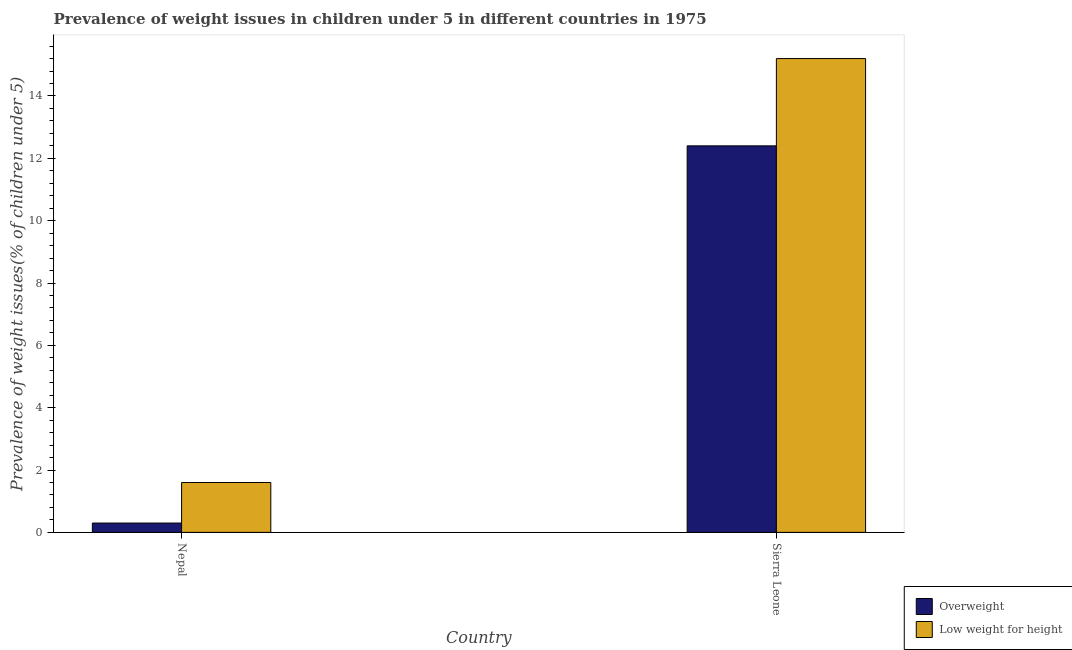How many groups of bars are there?
Make the answer very short. 2. Are the number of bars on each tick of the X-axis equal?
Your answer should be very brief. Yes. How many bars are there on the 2nd tick from the right?
Make the answer very short. 2. What is the label of the 1st group of bars from the left?
Provide a short and direct response. Nepal. In how many cases, is the number of bars for a given country not equal to the number of legend labels?
Keep it short and to the point. 0. What is the percentage of underweight children in Sierra Leone?
Your answer should be compact. 15.2. Across all countries, what is the maximum percentage of underweight children?
Your answer should be compact. 15.2. Across all countries, what is the minimum percentage of underweight children?
Provide a succinct answer. 1.6. In which country was the percentage of overweight children maximum?
Offer a very short reply. Sierra Leone. In which country was the percentage of overweight children minimum?
Ensure brevity in your answer.  Nepal. What is the total percentage of underweight children in the graph?
Your answer should be very brief. 16.8. What is the difference between the percentage of underweight children in Nepal and that in Sierra Leone?
Keep it short and to the point. -13.6. What is the difference between the percentage of underweight children in Sierra Leone and the percentage of overweight children in Nepal?
Your answer should be very brief. 14.9. What is the average percentage of underweight children per country?
Give a very brief answer. 8.4. What is the difference between the percentage of underweight children and percentage of overweight children in Nepal?
Ensure brevity in your answer.  1.3. In how many countries, is the percentage of underweight children greater than 4.4 %?
Offer a terse response. 1. What is the ratio of the percentage of overweight children in Nepal to that in Sierra Leone?
Your response must be concise. 0.02. What does the 1st bar from the left in Sierra Leone represents?
Give a very brief answer. Overweight. What does the 1st bar from the right in Sierra Leone represents?
Ensure brevity in your answer.  Low weight for height. How many bars are there?
Your response must be concise. 4. Are all the bars in the graph horizontal?
Ensure brevity in your answer.  No. How many countries are there in the graph?
Your answer should be very brief. 2. What is the difference between two consecutive major ticks on the Y-axis?
Offer a terse response. 2. Are the values on the major ticks of Y-axis written in scientific E-notation?
Your answer should be very brief. No. Does the graph contain any zero values?
Your answer should be compact. No. How are the legend labels stacked?
Ensure brevity in your answer.  Vertical. What is the title of the graph?
Provide a succinct answer. Prevalence of weight issues in children under 5 in different countries in 1975. Does "Automatic Teller Machines" appear as one of the legend labels in the graph?
Provide a succinct answer. No. What is the label or title of the Y-axis?
Give a very brief answer. Prevalence of weight issues(% of children under 5). What is the Prevalence of weight issues(% of children under 5) of Overweight in Nepal?
Your response must be concise. 0.3. What is the Prevalence of weight issues(% of children under 5) in Low weight for height in Nepal?
Offer a very short reply. 1.6. What is the Prevalence of weight issues(% of children under 5) in Overweight in Sierra Leone?
Make the answer very short. 12.4. What is the Prevalence of weight issues(% of children under 5) of Low weight for height in Sierra Leone?
Your answer should be compact. 15.2. Across all countries, what is the maximum Prevalence of weight issues(% of children under 5) in Overweight?
Ensure brevity in your answer.  12.4. Across all countries, what is the maximum Prevalence of weight issues(% of children under 5) of Low weight for height?
Provide a succinct answer. 15.2. Across all countries, what is the minimum Prevalence of weight issues(% of children under 5) in Overweight?
Your answer should be very brief. 0.3. Across all countries, what is the minimum Prevalence of weight issues(% of children under 5) in Low weight for height?
Give a very brief answer. 1.6. What is the difference between the Prevalence of weight issues(% of children under 5) of Overweight in Nepal and that in Sierra Leone?
Ensure brevity in your answer.  -12.1. What is the difference between the Prevalence of weight issues(% of children under 5) of Overweight in Nepal and the Prevalence of weight issues(% of children under 5) of Low weight for height in Sierra Leone?
Offer a very short reply. -14.9. What is the average Prevalence of weight issues(% of children under 5) of Overweight per country?
Your answer should be very brief. 6.35. What is the difference between the Prevalence of weight issues(% of children under 5) of Overweight and Prevalence of weight issues(% of children under 5) of Low weight for height in Sierra Leone?
Keep it short and to the point. -2.8. What is the ratio of the Prevalence of weight issues(% of children under 5) of Overweight in Nepal to that in Sierra Leone?
Your response must be concise. 0.02. What is the ratio of the Prevalence of weight issues(% of children under 5) in Low weight for height in Nepal to that in Sierra Leone?
Give a very brief answer. 0.11. What is the difference between the highest and the second highest Prevalence of weight issues(% of children under 5) of Overweight?
Give a very brief answer. 12.1. 